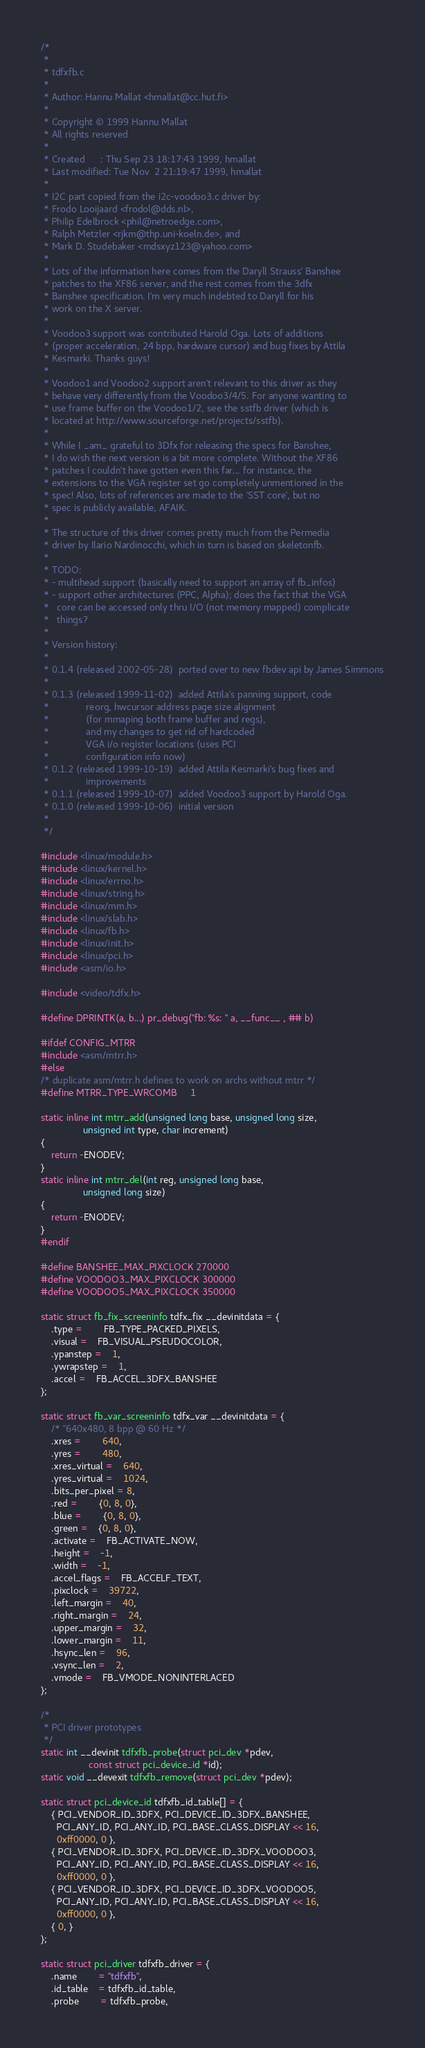Convert code to text. <code><loc_0><loc_0><loc_500><loc_500><_C_>/*
 *
 * tdfxfb.c
 *
 * Author: Hannu Mallat <hmallat@cc.hut.fi>
 *
 * Copyright © 1999 Hannu Mallat
 * All rights reserved
 *
 * Created      : Thu Sep 23 18:17:43 1999, hmallat
 * Last modified: Tue Nov  2 21:19:47 1999, hmallat
 *
 * I2C part copied from the i2c-voodoo3.c driver by:
 * Frodo Looijaard <frodol@dds.nl>,
 * Philip Edelbrock <phil@netroedge.com>,
 * Ralph Metzler <rjkm@thp.uni-koeln.de>, and
 * Mark D. Studebaker <mdsxyz123@yahoo.com>
 *
 * Lots of the information here comes from the Daryll Strauss' Banshee
 * patches to the XF86 server, and the rest comes from the 3dfx
 * Banshee specification. I'm very much indebted to Daryll for his
 * work on the X server.
 *
 * Voodoo3 support was contributed Harold Oga. Lots of additions
 * (proper acceleration, 24 bpp, hardware cursor) and bug fixes by Attila
 * Kesmarki. Thanks guys!
 *
 * Voodoo1 and Voodoo2 support aren't relevant to this driver as they
 * behave very differently from the Voodoo3/4/5. For anyone wanting to
 * use frame buffer on the Voodoo1/2, see the sstfb driver (which is
 * located at http://www.sourceforge.net/projects/sstfb).
 *
 * While I _am_ grateful to 3Dfx for releasing the specs for Banshee,
 * I do wish the next version is a bit more complete. Without the XF86
 * patches I couldn't have gotten even this far... for instance, the
 * extensions to the VGA register set go completely unmentioned in the
 * spec! Also, lots of references are made to the 'SST core', but no
 * spec is publicly available, AFAIK.
 *
 * The structure of this driver comes pretty much from the Permedia
 * driver by Ilario Nardinocchi, which in turn is based on skeletonfb.
 *
 * TODO:
 * - multihead support (basically need to support an array of fb_infos)
 * - support other architectures (PPC, Alpha); does the fact that the VGA
 *   core can be accessed only thru I/O (not memory mapped) complicate
 *   things?
 *
 * Version history:
 *
 * 0.1.4 (released 2002-05-28)	ported over to new fbdev api by James Simmons
 *
 * 0.1.3 (released 1999-11-02)	added Attila's panning support, code
 *				reorg, hwcursor address page size alignment
 *				(for mmaping both frame buffer and regs),
 *				and my changes to get rid of hardcoded
 *				VGA i/o register locations (uses PCI
 *				configuration info now)
 * 0.1.2 (released 1999-10-19)	added Attila Kesmarki's bug fixes and
 *				improvements
 * 0.1.1 (released 1999-10-07)	added Voodoo3 support by Harold Oga.
 * 0.1.0 (released 1999-10-06)	initial version
 *
 */

#include <linux/module.h>
#include <linux/kernel.h>
#include <linux/errno.h>
#include <linux/string.h>
#include <linux/mm.h>
#include <linux/slab.h>
#include <linux/fb.h>
#include <linux/init.h>
#include <linux/pci.h>
#include <asm/io.h>

#include <video/tdfx.h>

#define DPRINTK(a, b...) pr_debug("fb: %s: " a, __func__ , ## b)

#ifdef CONFIG_MTRR
#include <asm/mtrr.h>
#else
/* duplicate asm/mtrr.h defines to work on archs without mtrr */
#define MTRR_TYPE_WRCOMB     1

static inline int mtrr_add(unsigned long base, unsigned long size,
				unsigned int type, char increment)
{
    return -ENODEV;
}
static inline int mtrr_del(int reg, unsigned long base,
				unsigned long size)
{
    return -ENODEV;
}
#endif

#define BANSHEE_MAX_PIXCLOCK 270000
#define VOODOO3_MAX_PIXCLOCK 300000
#define VOODOO5_MAX_PIXCLOCK 350000

static struct fb_fix_screeninfo tdfx_fix __devinitdata = {
	.type =		FB_TYPE_PACKED_PIXELS,
	.visual =	FB_VISUAL_PSEUDOCOLOR,
	.ypanstep =	1,
	.ywrapstep =	1,
	.accel =	FB_ACCEL_3DFX_BANSHEE
};

static struct fb_var_screeninfo tdfx_var __devinitdata = {
	/* "640x480, 8 bpp @ 60 Hz */
	.xres =		640,
	.yres =		480,
	.xres_virtual =	640,
	.yres_virtual =	1024,
	.bits_per_pixel = 8,
	.red =		{0, 8, 0},
	.blue =		{0, 8, 0},
	.green =	{0, 8, 0},
	.activate =	FB_ACTIVATE_NOW,
	.height =	-1,
	.width =	-1,
	.accel_flags =	FB_ACCELF_TEXT,
	.pixclock =	39722,
	.left_margin =	40,
	.right_margin =	24,
	.upper_margin =	32,
	.lower_margin =	11,
	.hsync_len =	96,
	.vsync_len =	2,
	.vmode =	FB_VMODE_NONINTERLACED
};

/*
 * PCI driver prototypes
 */
static int __devinit tdfxfb_probe(struct pci_dev *pdev,
				  const struct pci_device_id *id);
static void __devexit tdfxfb_remove(struct pci_dev *pdev);

static struct pci_device_id tdfxfb_id_table[] = {
	{ PCI_VENDOR_ID_3DFX, PCI_DEVICE_ID_3DFX_BANSHEE,
	  PCI_ANY_ID, PCI_ANY_ID, PCI_BASE_CLASS_DISPLAY << 16,
	  0xff0000, 0 },
	{ PCI_VENDOR_ID_3DFX, PCI_DEVICE_ID_3DFX_VOODOO3,
	  PCI_ANY_ID, PCI_ANY_ID, PCI_BASE_CLASS_DISPLAY << 16,
	  0xff0000, 0 },
	{ PCI_VENDOR_ID_3DFX, PCI_DEVICE_ID_3DFX_VOODOO5,
	  PCI_ANY_ID, PCI_ANY_ID, PCI_BASE_CLASS_DISPLAY << 16,
	  0xff0000, 0 },
	{ 0, }
};

static struct pci_driver tdfxfb_driver = {
	.name		= "tdfxfb",
	.id_table	= tdfxfb_id_table,
	.probe		= tdfxfb_probe,</code> 